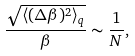<formula> <loc_0><loc_0><loc_500><loc_500>\frac { \sqrt { \langle ( \Delta { \beta } ) ^ { 2 } \rangle _ { q } } } { \beta } \sim \frac { 1 } { N } ,</formula> 